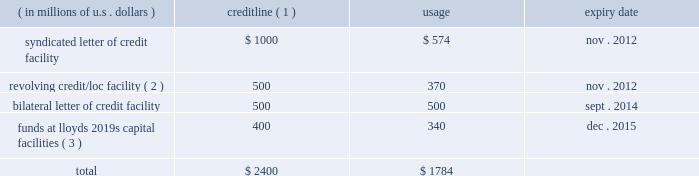Credit facilities as our bermuda subsidiaries are not admitted insurers and reinsurers in the u.s. , the terms of certain u.s .
Insurance and reinsurance contracts require them to provide collateral , which can be in the form of locs .
In addition , ace global markets is required to satisfy certain u.s .
Regulatory trust fund requirements which can be met by the issuance of locs .
Locs may also be used for general corporate purposes and to provide underwriting capacity as funds at lloyd 2019s .
The table shows our main credit facilities by credit line , usage , and expiry date at december 31 , 2010 .
( in millions of u.s .
Dollars ) credit line ( 1 ) usage expiry date .
( 1 ) certain facilities are guaranteed by operating subsidiaries and/or ace limited .
( 2 ) may also be used for locs .
( 3 ) supports ace global markets underwriting capacity for lloyd 2019s syndicate 2488 ( see discussion below ) .
In november 2010 , we entered into four letter of credit facility agreements which collectively permit the issuance of up to $ 400 million of letters of credit .
We expect that most of the locs issued under the loc agreements will be used to support the ongoing funds at lloyd 2019s requirements of syndicate 2488 , but locs may also be used for other general corporate purposes .
It is anticipated that our commercial facilities will be renewed on expiry but such renewals are subject to the availability of credit from banks utilized by ace .
In the event that such credit support is insufficient , we could be required to provide alter- native security to clients .
This could take the form of additional insurance trusts supported by our investment portfolio or funds withheld using our cash resources .
The value of letters of credit required is driven by , among other things , statutory liabilities reported by variable annuity guarantee reinsurance clients , loss development of existing reserves , the payment pattern of such reserves , the expansion of business , and loss experience of such business .
The facilities in the table above require that we maintain certain covenants , all of which have been met at december 31 , 2010 .
These covenants include : ( i ) maintenance of a minimum consolidated net worth in an amount not less than the 201cminimum amount 201d .
For the purpose of this calculation , the minimum amount is an amount equal to the sum of the base amount ( currently $ 13.8 billion ) plus 25 percent of consolidated net income for each fiscal quarter , ending after the date on which the current base amount became effective , plus 50 percent of any increase in consolidated net worth during the same period , attributable to the issuance of common and preferred shares .
The minimum amount is subject to an annual reset provision .
( ii ) maintenance of a maximum debt to total capitalization ratio of not greater than 0.35 to 1 .
Under this covenant , debt does not include trust preferred securities or mezzanine equity , except where the ratio of the sum of trust preferred securities and mezzanine equity to total capitalization is greater than 15 percent .
In this circumstance , the amount greater than 15 percent would be included in the debt to total capitalization ratio .
At december 31 , 2010 , ( a ) the minimum consolidated net worth requirement under the covenant described in ( i ) above was $ 14.5 billion and our actual consolidated net worth as calculated under that covenant was $ 21.6 billion and ( b ) our ratio of debt to total capitalization was 0.167 to 1 , which is below the maximum debt to total capitalization ratio of 0.35 to 1 as described in ( ii ) above .
Our failure to comply with the covenants under any credit facility would , subject to grace periods in the case of certain covenants , result in an event of default .
This could require us to repay any outstanding borrowings or to cash collateralize locs under such facility .
A failure by ace limited ( or any of its subsidiaries ) to pay an obligation due for an amount exceeding $ 50 million would result in an event of default under all of the facilities described above .
Ratings ace limited and its subsidiaries are assigned debt and financial strength ( insurance ) ratings from internationally recognized rating agencies , including s&p , a.m .
Best , moody 2019s investors service , and fitch .
The ratings issued on our companies by these agencies are announced publicly and are available directly from the agencies .
Our internet site , www.acegroup.com .
In 2010 what was the percent of the credit utilization? 
Computations: (1784 / 2400)
Answer: 0.74333. 